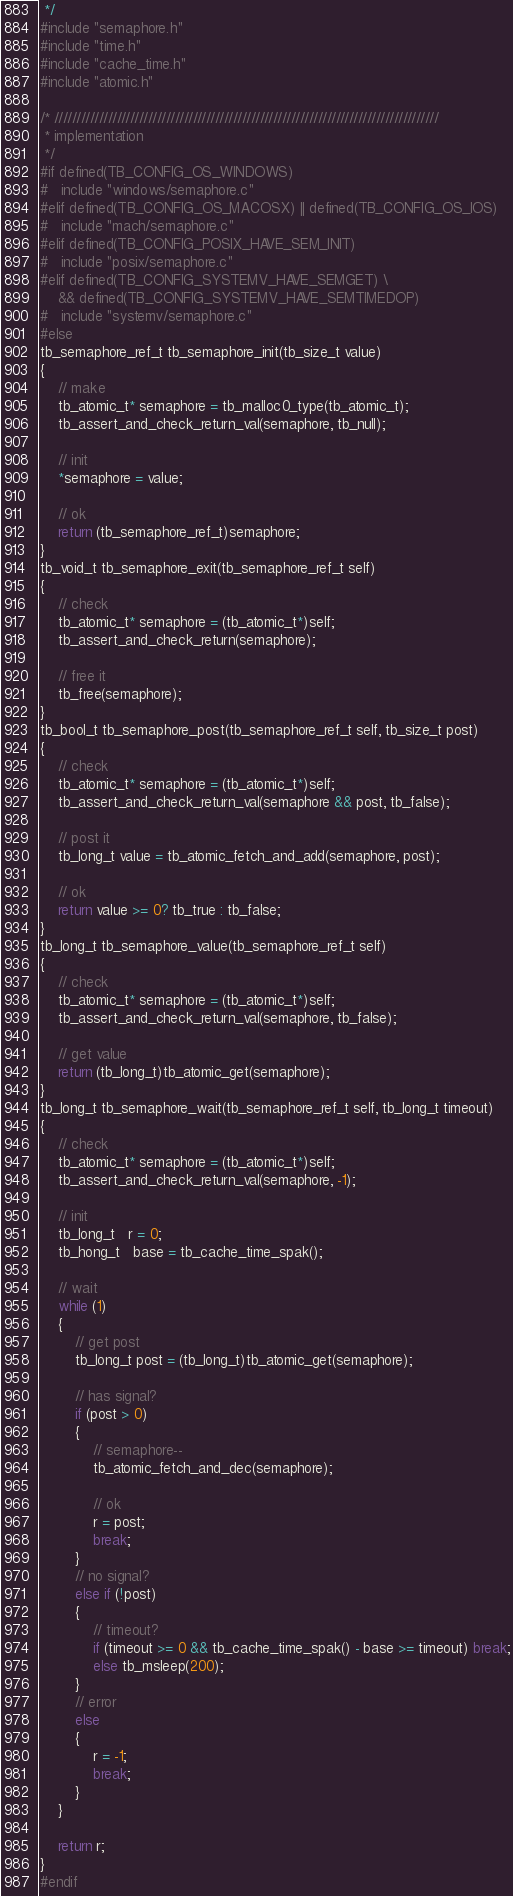Convert code to text. <code><loc_0><loc_0><loc_500><loc_500><_C_> */
#include "semaphore.h"
#include "time.h"
#include "cache_time.h"
#include "atomic.h"

/* //////////////////////////////////////////////////////////////////////////////////////
 * implementation
 */
#if defined(TB_CONFIG_OS_WINDOWS)
#   include "windows/semaphore.c"
#elif defined(TB_CONFIG_OS_MACOSX) || defined(TB_CONFIG_OS_IOS)
#   include "mach/semaphore.c"
#elif defined(TB_CONFIG_POSIX_HAVE_SEM_INIT)
#   include "posix/semaphore.c"
#elif defined(TB_CONFIG_SYSTEMV_HAVE_SEMGET) \
    && defined(TB_CONFIG_SYSTEMV_HAVE_SEMTIMEDOP)
#   include "systemv/semaphore.c"
#else 
tb_semaphore_ref_t tb_semaphore_init(tb_size_t value)
{
    // make
    tb_atomic_t* semaphore = tb_malloc0_type(tb_atomic_t);
    tb_assert_and_check_return_val(semaphore, tb_null);

    // init
    *semaphore = value;

    // ok
    return (tb_semaphore_ref_t)semaphore;
}
tb_void_t tb_semaphore_exit(tb_semaphore_ref_t self)
{
    // check
    tb_atomic_t* semaphore = (tb_atomic_t*)self;
    tb_assert_and_check_return(semaphore);

    // free it
    tb_free(semaphore);
}
tb_bool_t tb_semaphore_post(tb_semaphore_ref_t self, tb_size_t post)
{
    // check
    tb_atomic_t* semaphore = (tb_atomic_t*)self;
    tb_assert_and_check_return_val(semaphore && post, tb_false);

    // post it
    tb_long_t value = tb_atomic_fetch_and_add(semaphore, post);

    // ok
    return value >= 0? tb_true : tb_false;
}
tb_long_t tb_semaphore_value(tb_semaphore_ref_t self)
{
    // check
    tb_atomic_t* semaphore = (tb_atomic_t*)self;
    tb_assert_and_check_return_val(semaphore, tb_false);

    // get value
    return (tb_long_t)tb_atomic_get(semaphore);
}
tb_long_t tb_semaphore_wait(tb_semaphore_ref_t self, tb_long_t timeout)
{
    // check
    tb_atomic_t* semaphore = (tb_atomic_t*)self;
    tb_assert_and_check_return_val(semaphore, -1);

    // init
    tb_long_t   r = 0;
    tb_hong_t   base = tb_cache_time_spak();

    // wait 
    while (1)
    {
        // get post
        tb_long_t post = (tb_long_t)tb_atomic_get(semaphore);

        // has signal?
        if (post > 0) 
        {
            // semaphore--
            tb_atomic_fetch_and_dec(semaphore);

            // ok
            r = post;
            break;
        }
        // no signal?
        else if (!post)
        {
            // timeout?
            if (timeout >= 0 && tb_cache_time_spak() - base >= timeout) break;
            else tb_msleep(200);
        }
        // error
        else
        {
            r = -1;
            break;
        }
    }

    return r;
}
#endif

</code> 